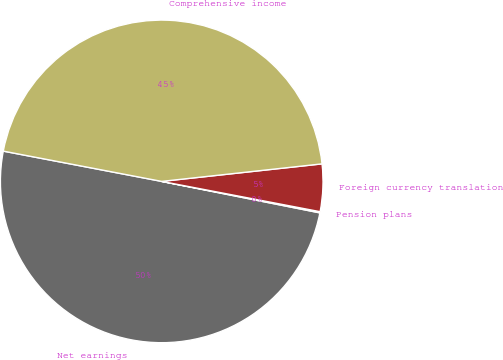Convert chart. <chart><loc_0><loc_0><loc_500><loc_500><pie_chart><fcel>Net earnings<fcel>Pension plans<fcel>Foreign currency translation<fcel>Comprehensive income<nl><fcel>49.88%<fcel>0.12%<fcel>4.74%<fcel>45.26%<nl></chart> 